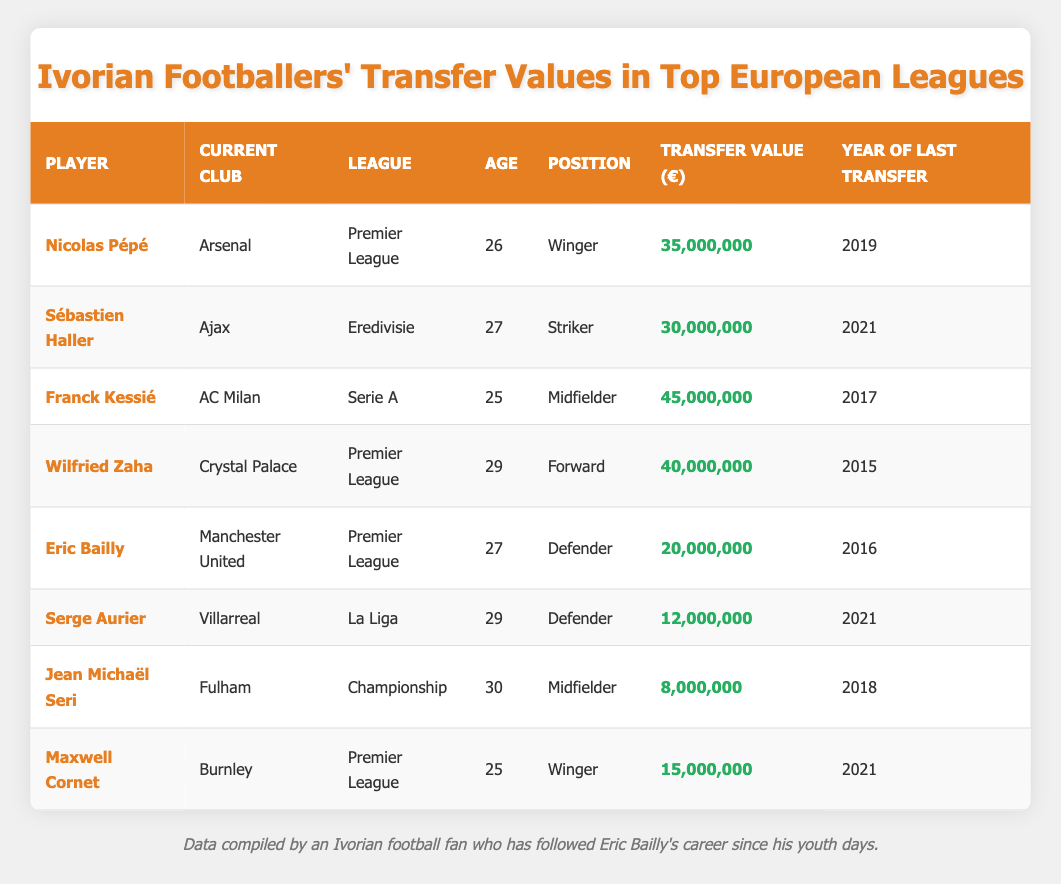What is the highest transfer value among the players listed? To find the highest transfer value, I need to look through the "Transfer Value (€)" column. The highest value is 45,000,000 for Franck Kessié.
Answer: 45,000,000 Which player has the lowest transfer value? Scanning the "Transfer Value (€)" column reveals that Jean Michaël Seri has the lowest value at 8,000,000.
Answer: 8,000,000 How many players are currently playing in the Premier League? I will count the number of players listed under "League" that indicate Premier League. The players are Nicolas Pépé, Wilfried Zaha, and Eric Bailly, totaling 3 players.
Answer: 3 What is the average transfer value of all the players in the dataset? To calculate the average, I will sum the transfer values (35,000,000 + 30,000,000 + 45,000,000 + 40,000,000 + 20,000,000 + 12,000,000 + 8,000,000 + 15,000,000 = 200,000,000). There are 8 players, so the average is 200,000,000 / 8 = 25,000,000.
Answer: 25,000,000 Is Eric Bailly older than Franck Kessié? Eric Bailly is 27 years old, and Franck Kessié is 25 years old. Since 27 is greater than 25, the statement is true.
Answer: Yes Which team does Serge Aurier currently play for, and what is his transfer value? Looking at the "Current Club" column, Serge Aurier is with Villarreal. Referring to his "Transfer Value (€)", it is 12,000,000.
Answer: Villarreal, 12,000,000 What is the difference in transfer value between Wilfried Zaha and Eric Bailly? To find the difference, I subtract Eric Bailly's transfer value (20,000,000) from Wilfried Zaha's transfer value (40,000,000) which equals 20,000,000.
Answer: 20,000,000 How many players are under the age of 30? I check the "Age" column and find that the players under 30 are Nicolas Pépé (26), Franck Kessié (25), and Maxwell Cornet (25), making a total of 5 players.
Answer: 5 